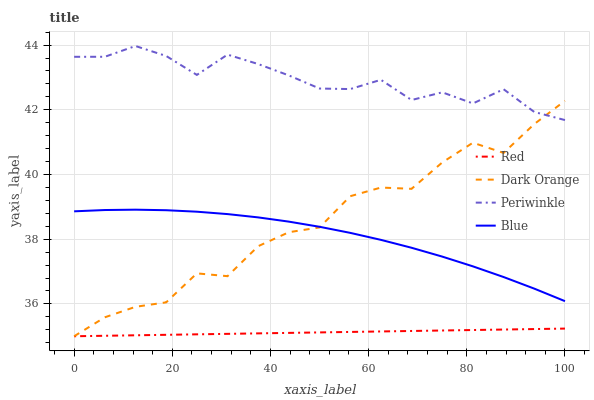Does Red have the minimum area under the curve?
Answer yes or no. Yes. Does Periwinkle have the maximum area under the curve?
Answer yes or no. Yes. Does Dark Orange have the minimum area under the curve?
Answer yes or no. No. Does Dark Orange have the maximum area under the curve?
Answer yes or no. No. Is Red the smoothest?
Answer yes or no. Yes. Is Dark Orange the roughest?
Answer yes or no. Yes. Is Periwinkle the smoothest?
Answer yes or no. No. Is Periwinkle the roughest?
Answer yes or no. No. Does Dark Orange have the lowest value?
Answer yes or no. Yes. Does Periwinkle have the lowest value?
Answer yes or no. No. Does Periwinkle have the highest value?
Answer yes or no. Yes. Does Dark Orange have the highest value?
Answer yes or no. No. Is Red less than Blue?
Answer yes or no. Yes. Is Periwinkle greater than Red?
Answer yes or no. Yes. Does Dark Orange intersect Red?
Answer yes or no. Yes. Is Dark Orange less than Red?
Answer yes or no. No. Is Dark Orange greater than Red?
Answer yes or no. No. Does Red intersect Blue?
Answer yes or no. No. 